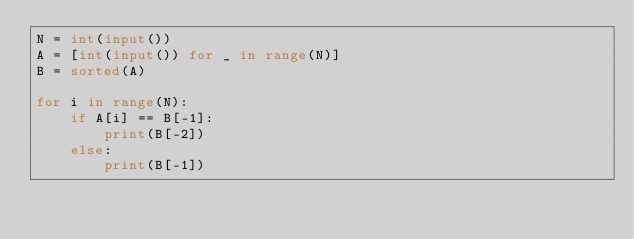<code> <loc_0><loc_0><loc_500><loc_500><_Python_>N = int(input())
A = [int(input()) for _ in range(N)]
B = sorted(A)

for i in range(N):
    if A[i] == B[-1]:
        print(B[-2])
    else:
        print(B[-1])
</code> 